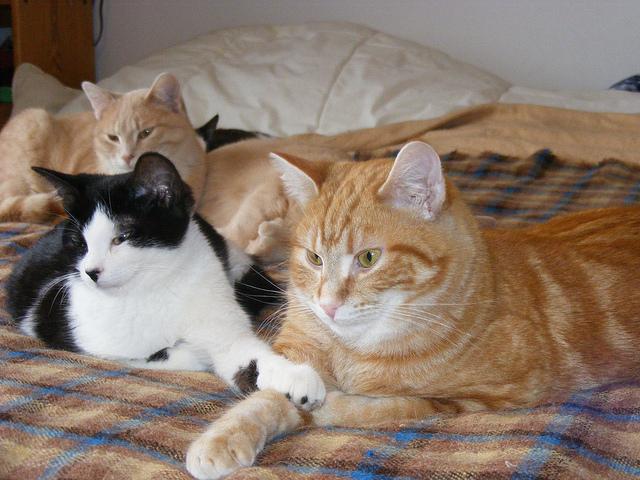What color are most of the cats?
Be succinct. Orange. What breed of cat is in the photo?
Answer briefly. Tabby. How many cats are in this picture?
Answer briefly. 3. How many cats?
Keep it brief. 3. Are these cats outside?
Concise answer only. No. What are the cats lying on?
Concise answer only. Bed. 